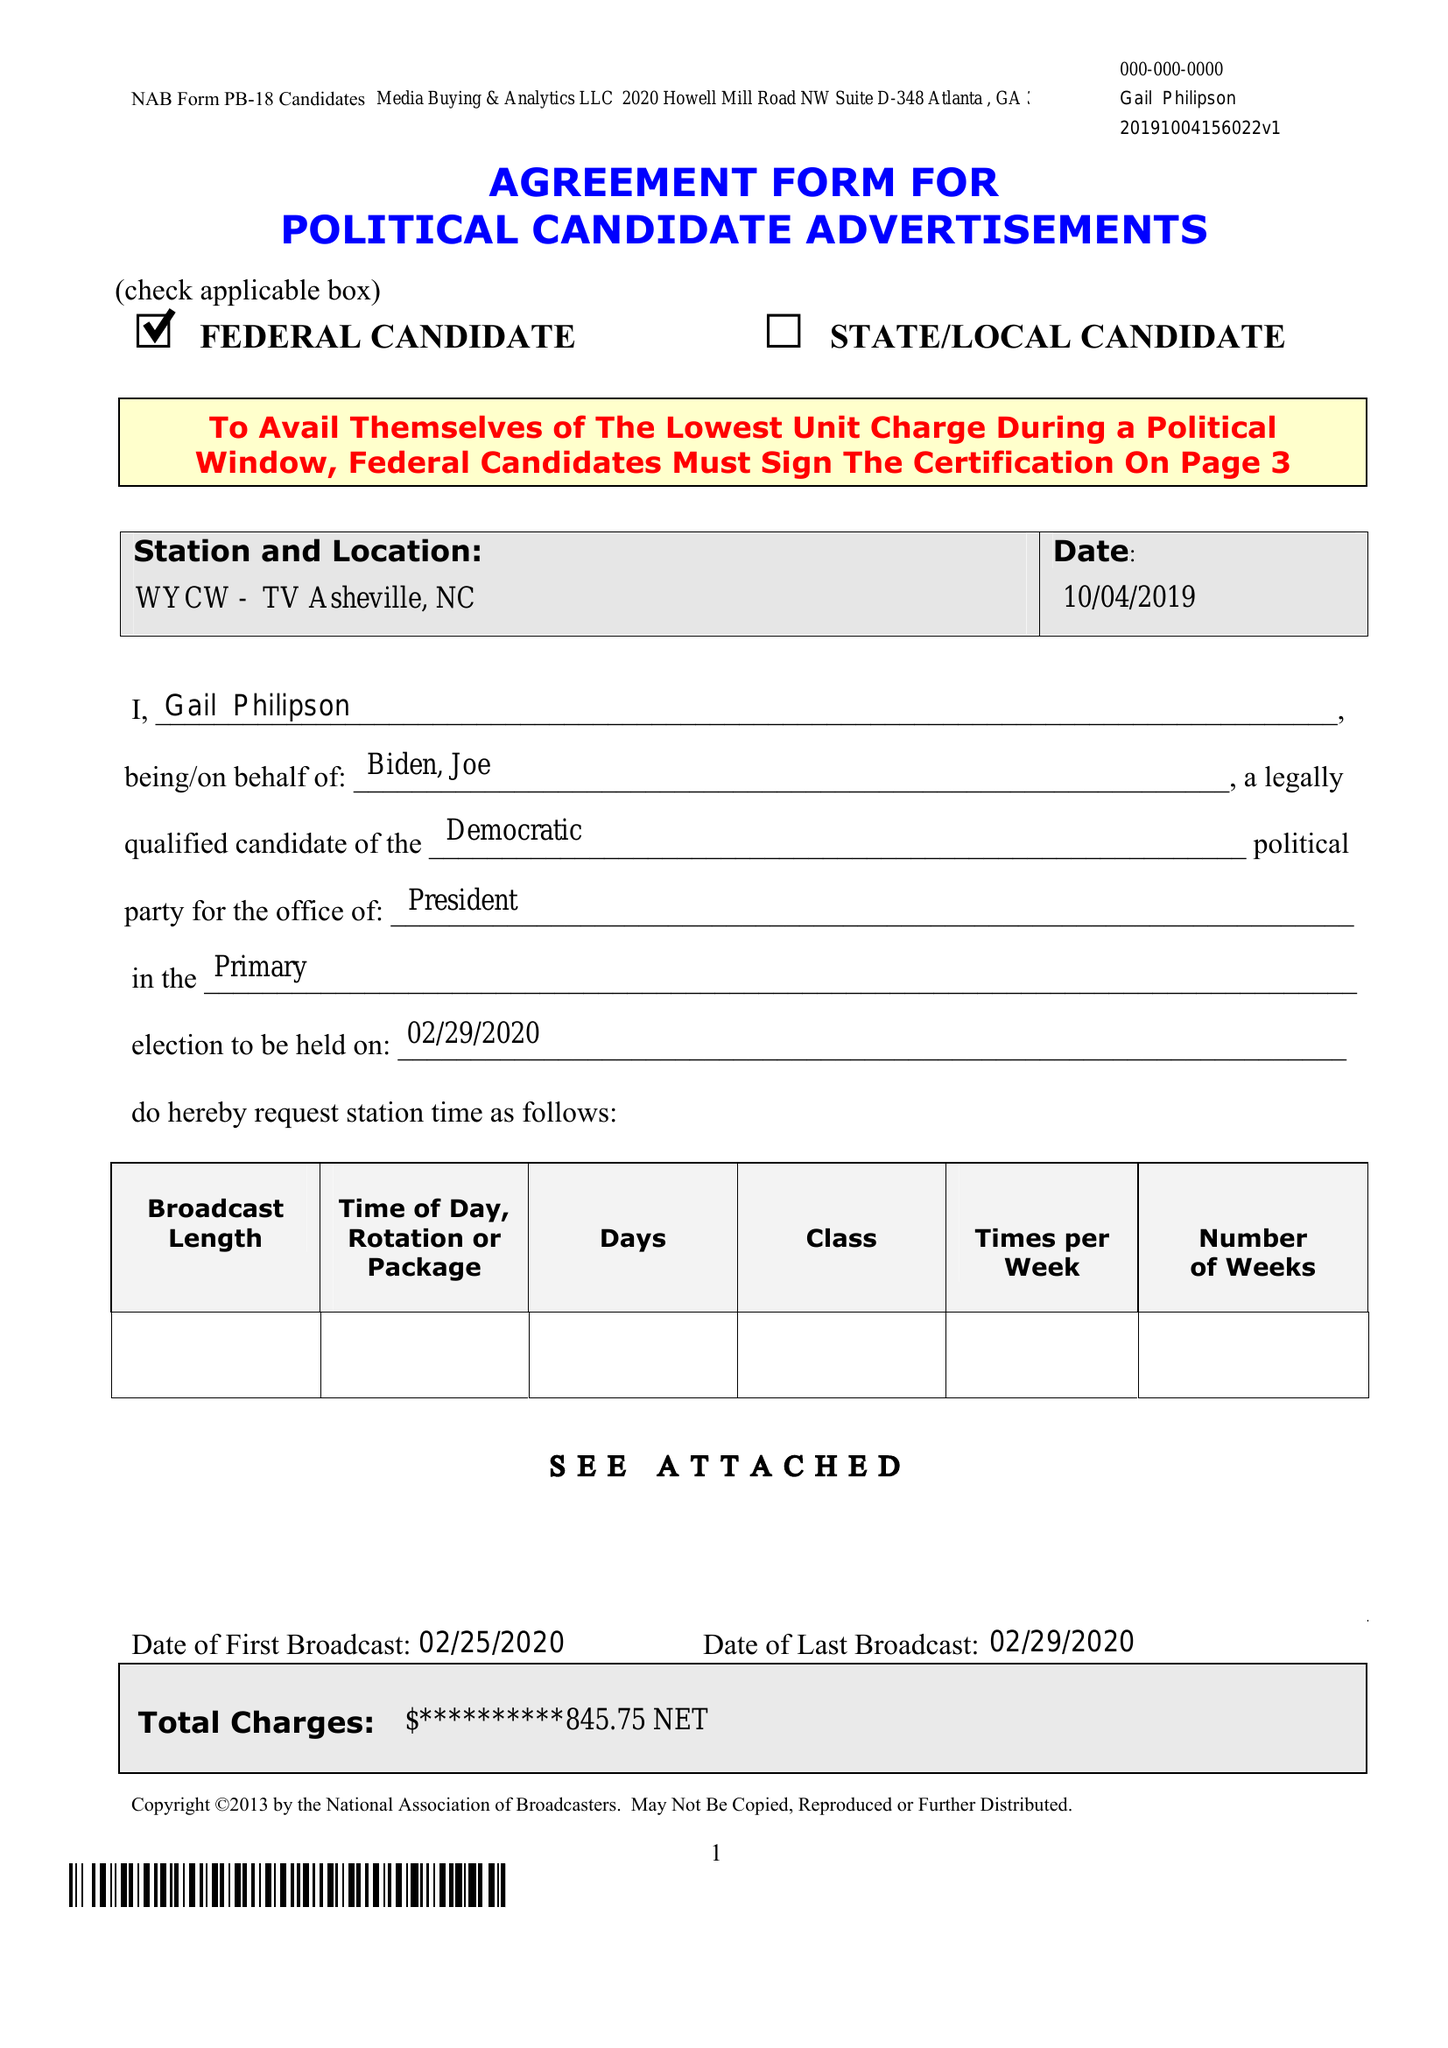What is the value for the gross_amount?
Answer the question using a single word or phrase. None 